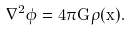<formula> <loc_0><loc_0><loc_500><loc_500>\nabla ^ { 2 } \phi = 4 \pi G \rho ( \vec { x } ) .</formula> 